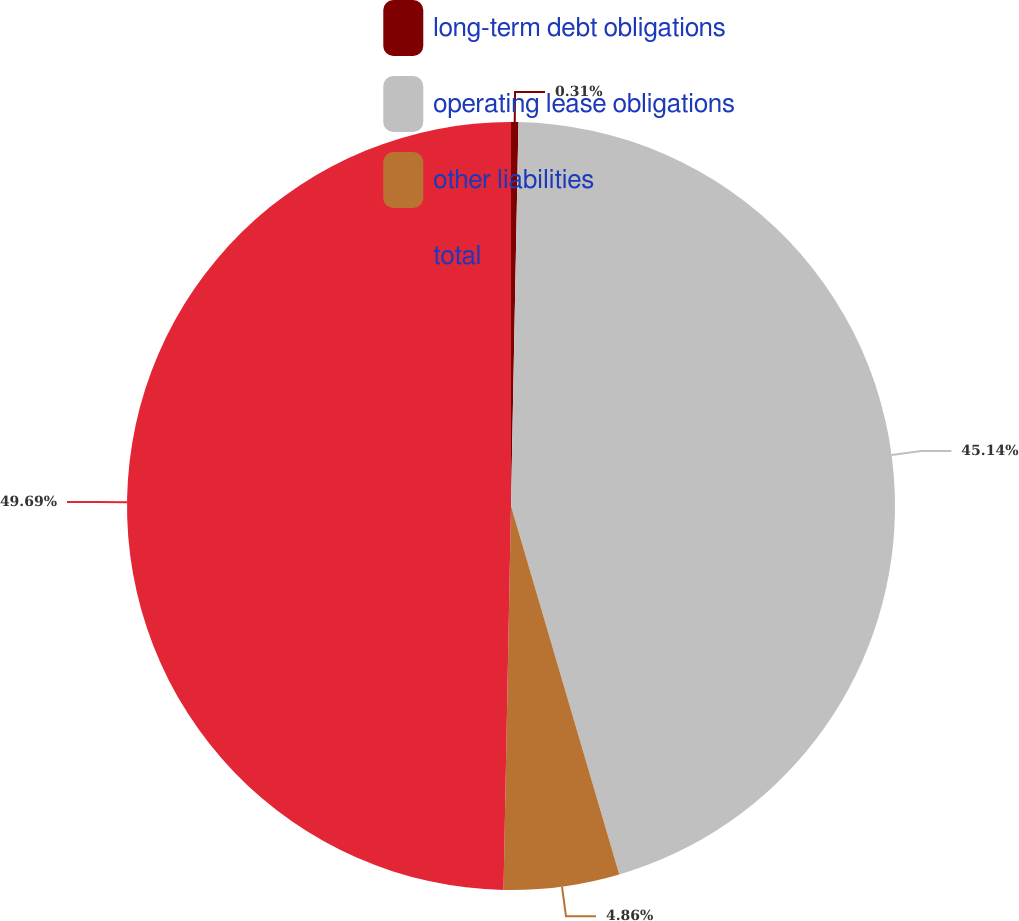Convert chart to OTSL. <chart><loc_0><loc_0><loc_500><loc_500><pie_chart><fcel>long-term debt obligations<fcel>operating lease obligations<fcel>other liabilities<fcel>total<nl><fcel>0.31%<fcel>45.14%<fcel>4.86%<fcel>49.69%<nl></chart> 